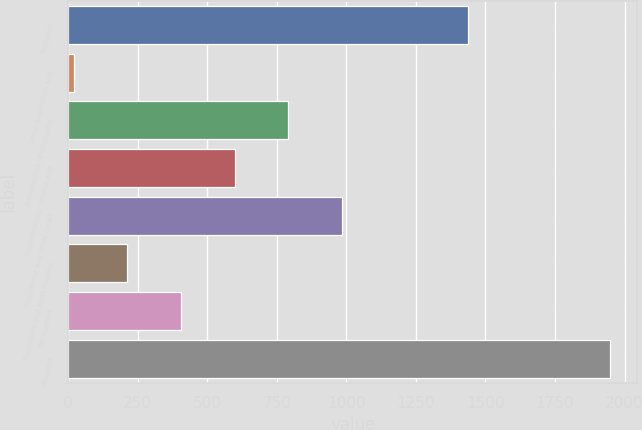Convert chart. <chart><loc_0><loc_0><loc_500><loc_500><bar_chart><fcel>Reported<fcel>Other acquisition and<fcel>Amortization of intangible<fcel>Restructuring- related and<fcel>Rejuvenate and other recall<fcel>Regulatory and legal matters<fcel>Tax matters<fcel>Adjusted<nl><fcel>1439<fcel>20<fcel>791.6<fcel>598.7<fcel>984.5<fcel>212.9<fcel>405.8<fcel>1949<nl></chart> 